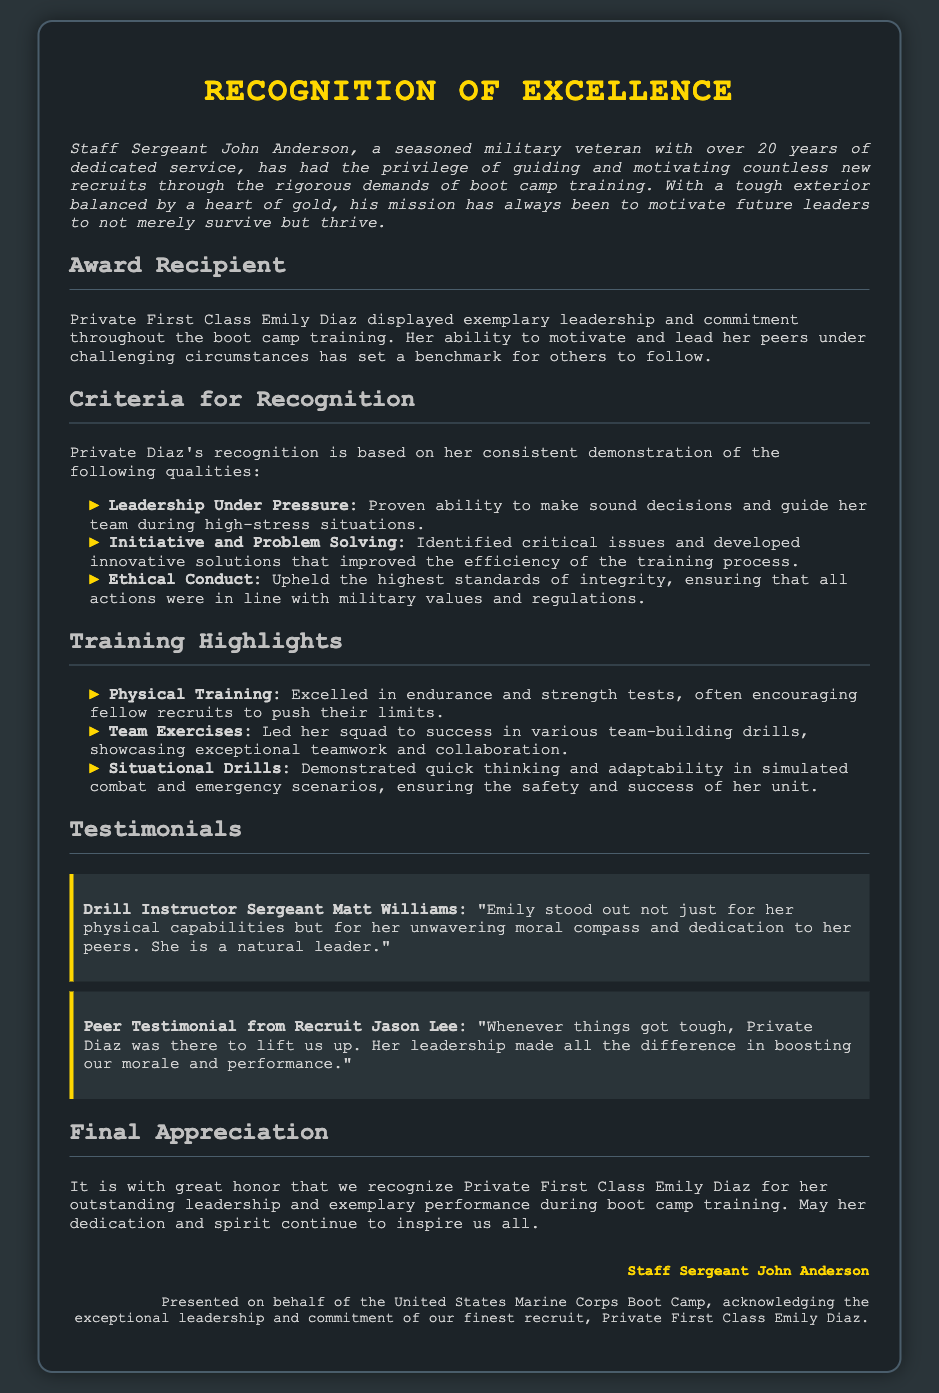What is the title of the document? The title of the document is prominently displayed at the top.
Answer: Recognition of Excellence Who is the award recipient? The award recipient's name is mentioned in the section dedicated to the award recipient.
Answer: Private First Class Emily Diaz How many years of service does Staff Sergeant John Anderson have? The document states the years of service in the introduction.
Answer: 20 years What three qualities are highlighted for Private Diaz's recognition? The qualities are listed under the criteria for recognition section.
Answer: Leadership Under Pressure, Initiative and Problem Solving, Ethical Conduct What role does Sergeant Matt Williams have? The document specifies his role in connection with the testimonial section.
Answer: Drill Instructor What specific type of training did Private Diaz excel in? The training type is mentioned in the training highlights section.
Answer: Physical Training During which drills did Private Diaz showcase exceptional teamwork? The specific drills are mentioned under training highlights.
Answer: Team Exercises What is the focus of the final appreciation section? The focus is stated in the summarizing statement at the end.
Answer: Honor for outstanding leadership Who presented this recognition? The document indicates who made the presentation in the footer.
Answer: Staff Sergeant John Anderson 